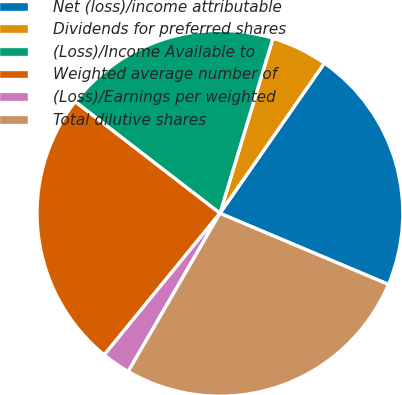Convert chart to OTSL. <chart><loc_0><loc_0><loc_500><loc_500><pie_chart><fcel>Net (loss)/income attributable<fcel>Dividends for preferred shares<fcel>(Loss)/Income Available to<fcel>Weighted average number of<fcel>(Loss)/Earnings per weighted<fcel>Total dilutive shares<nl><fcel>21.69%<fcel>4.99%<fcel>19.23%<fcel>24.55%<fcel>2.54%<fcel>27.01%<nl></chart> 